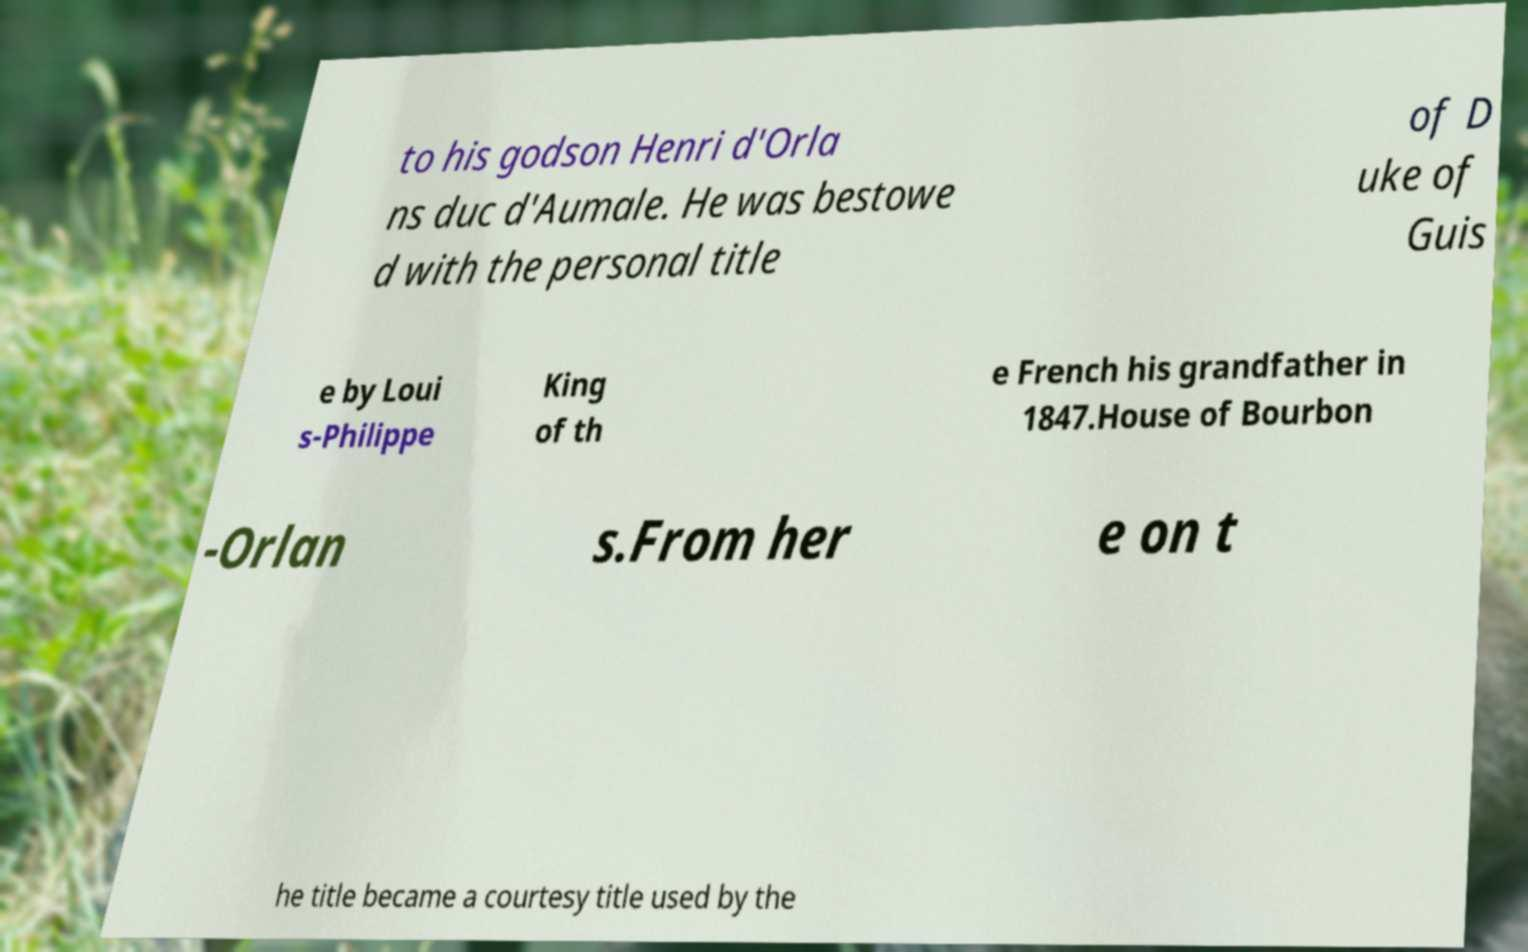Can you read and provide the text displayed in the image?This photo seems to have some interesting text. Can you extract and type it out for me? to his godson Henri d'Orla ns duc d'Aumale. He was bestowe d with the personal title of D uke of Guis e by Loui s-Philippe King of th e French his grandfather in 1847.House of Bourbon -Orlan s.From her e on t he title became a courtesy title used by the 